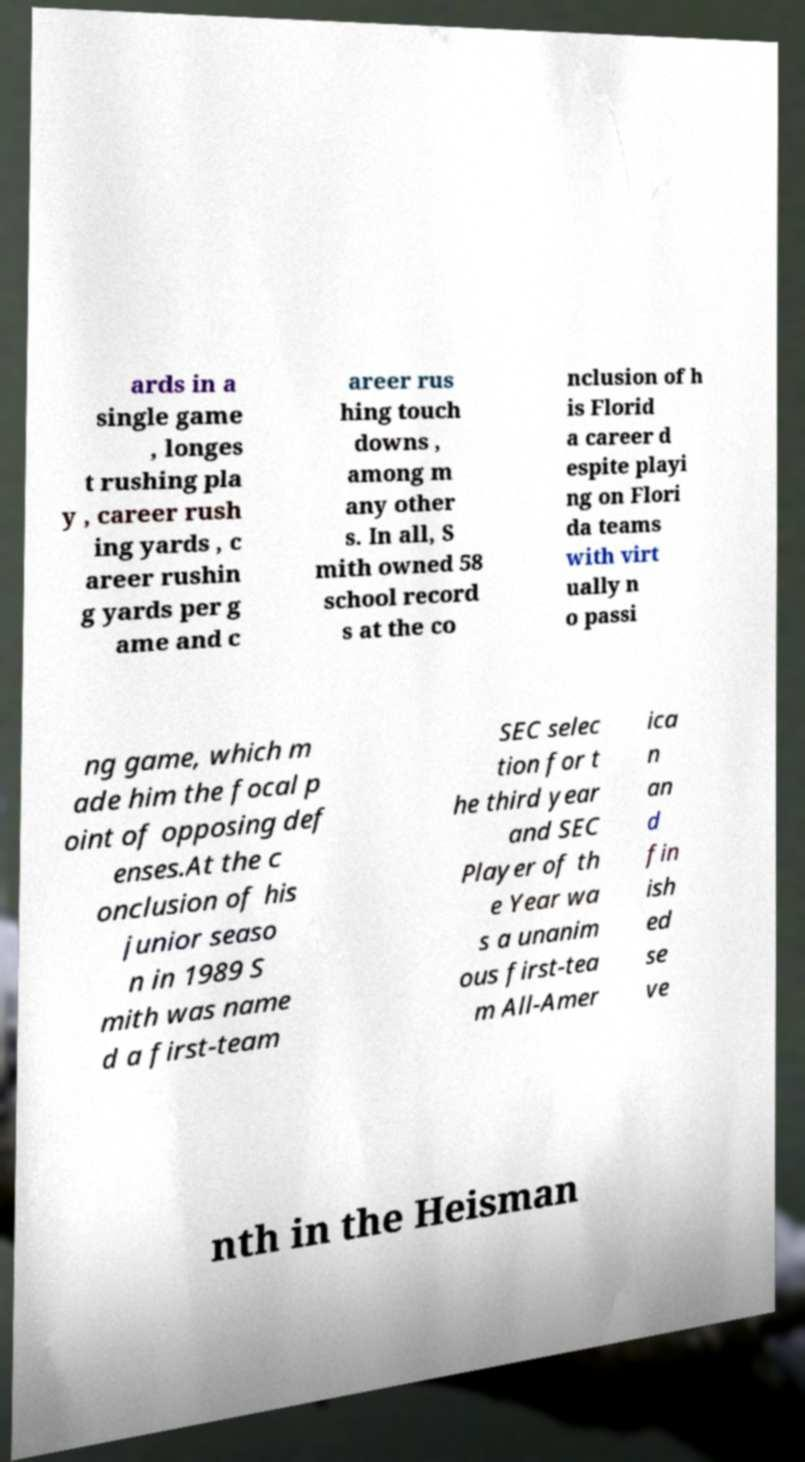Could you assist in decoding the text presented in this image and type it out clearly? ards in a single game , longes t rushing pla y , career rush ing yards , c areer rushin g yards per g ame and c areer rus hing touch downs , among m any other s. In all, S mith owned 58 school record s at the co nclusion of h is Florid a career d espite playi ng on Flori da teams with virt ually n o passi ng game, which m ade him the focal p oint of opposing def enses.At the c onclusion of his junior seaso n in 1989 S mith was name d a first-team SEC selec tion for t he third year and SEC Player of th e Year wa s a unanim ous first-tea m All-Amer ica n an d fin ish ed se ve nth in the Heisman 